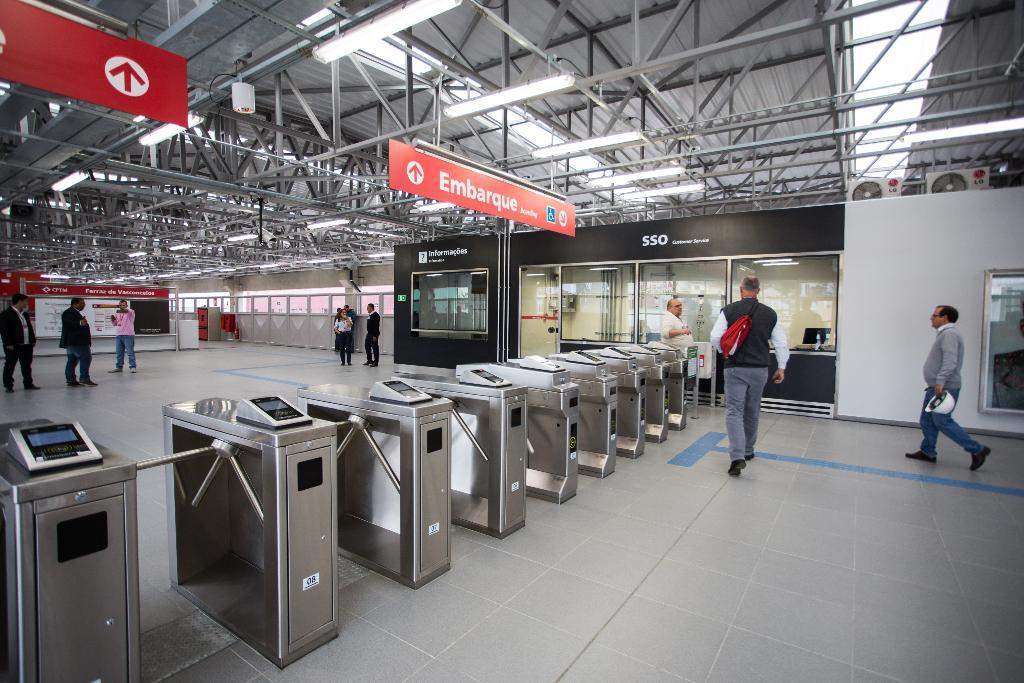Provide a one-sentence caption for the provided image. A far away shot of some turnstiles in front of a banner for SSO. 